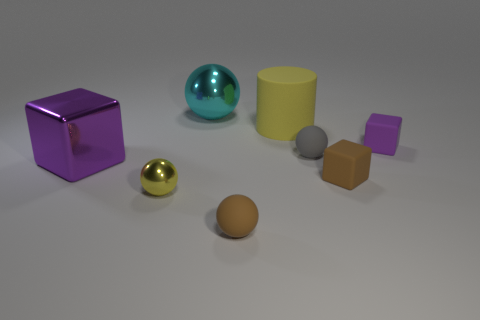Are there more tiny brown matte spheres that are behind the tiny metal thing than purple metallic objects? no 